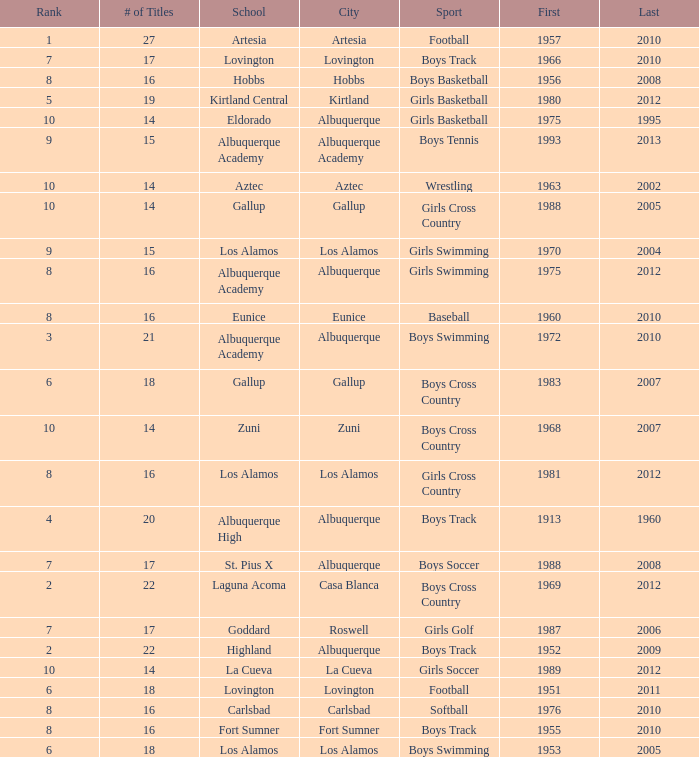What city is the school that had less than 17 titles in boys basketball with the last title being after 2005? Hobbs. 